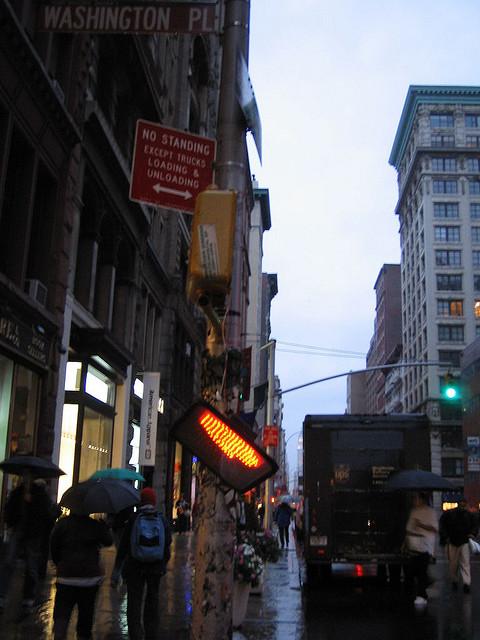Is the photo from North America?
Concise answer only. Yes. Is this an overcast day?
Answer briefly. Yes. Is this a one way street?
Write a very short answer. No. Why are some of the people holding umbrellas?
Short answer required. Raining. Is the lite sign suppose to be faced in this direction?
Quick response, please. No. What color is the traffic light?
Write a very short answer. Green. What color is the light?
Be succinct. Green. 